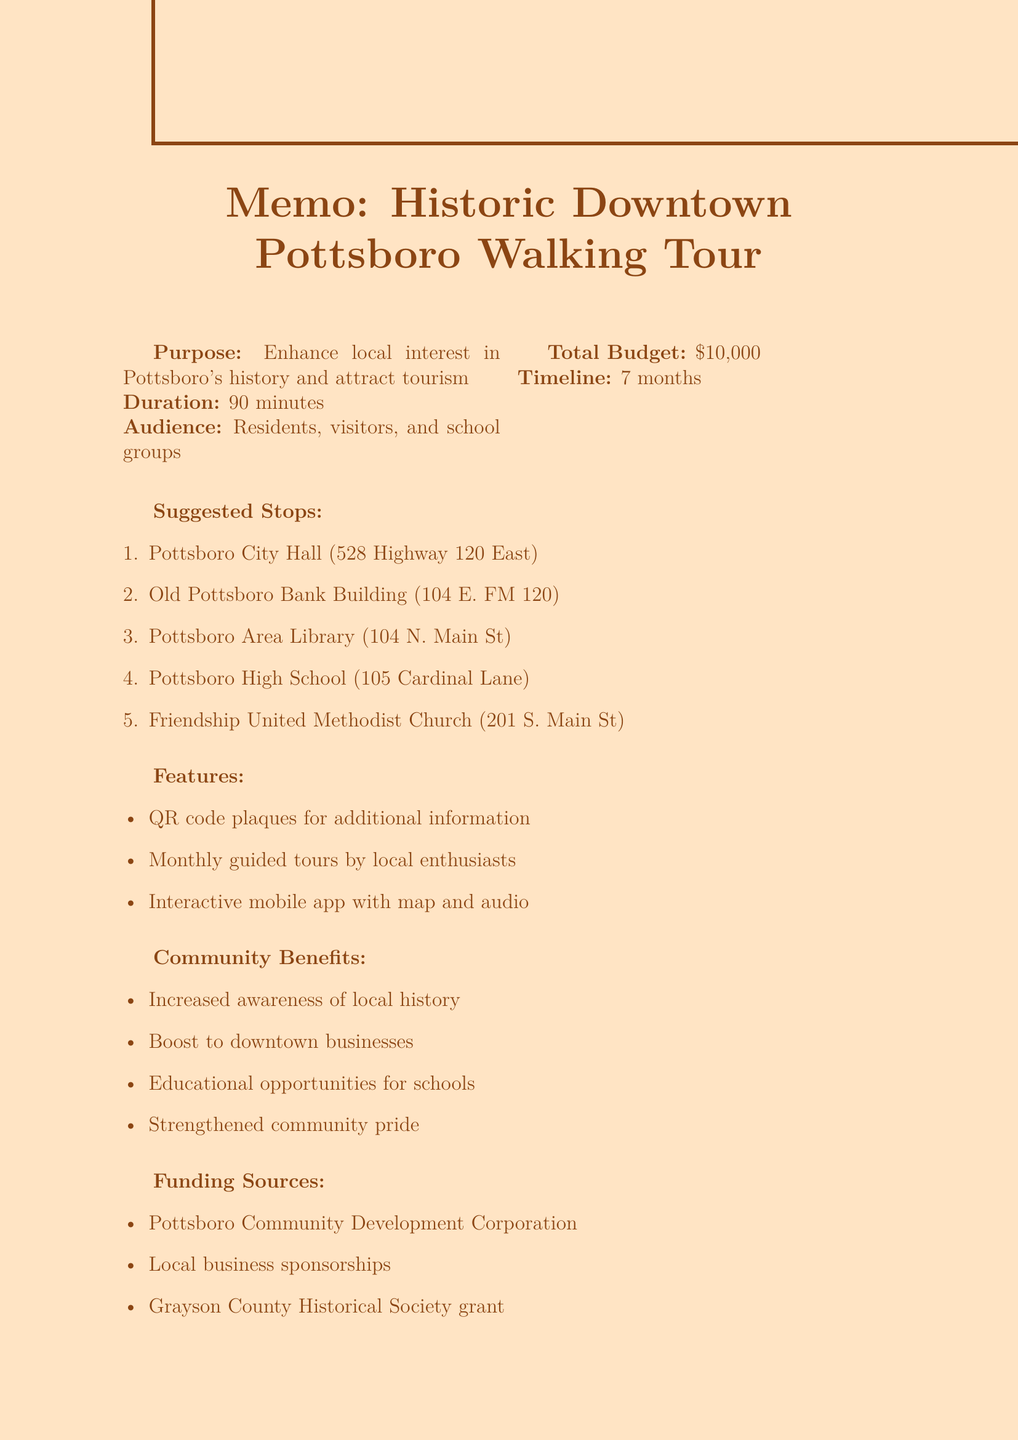What is the purpose of the walking tour proposal? The purpose is to enhance local interest in Pottsboro's rich history and attract tourism.
Answer: Enhance local interest in Pottsboro's rich history and attract tourism How long is the proposed walking tour? The proposed duration is specifically mentioned in the introduction of the document.
Answer: 90 minutes What is the address of Friendship United Methodist Church? The address is provided in the suggested stops section of the memo.
Answer: 201 S. Main St What significant event occurred at Pottsboro City Hall in 1957? The historical significance of City Hall includes its role during a specific event mentioned in the document.
Answer: Makeshift shelter for displaced residents What is the total budget for the proposal? The total budget is summarized in the memo under budget estimate.
Answer: $10,000 How many months does the implementation timeline state for initial research and planning? The timeline for research and planning is detailed in the implementation timeline section.
Answer: 2 months What feature involves QR codes? One of the additional features proposed includes installing QR codes.
Answer: QR code plaques Which organization is mentioned as a potential funding source? The funding sources listed include various organizations and efforts, specifically noted in the funding sources section.
Answer: Grayson County Historical Society grant What is the call to action included in the proposal? The conclusion section specifies what action is urged upon the readers of the memo.
Answer: Approve the proposal and form a committee to oversee implementation 